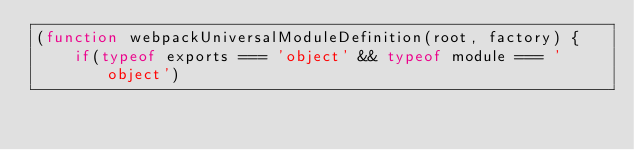Convert code to text. <code><loc_0><loc_0><loc_500><loc_500><_JavaScript_>(function webpackUniversalModuleDefinition(root, factory) {
	if(typeof exports === 'object' && typeof module === 'object')</code> 